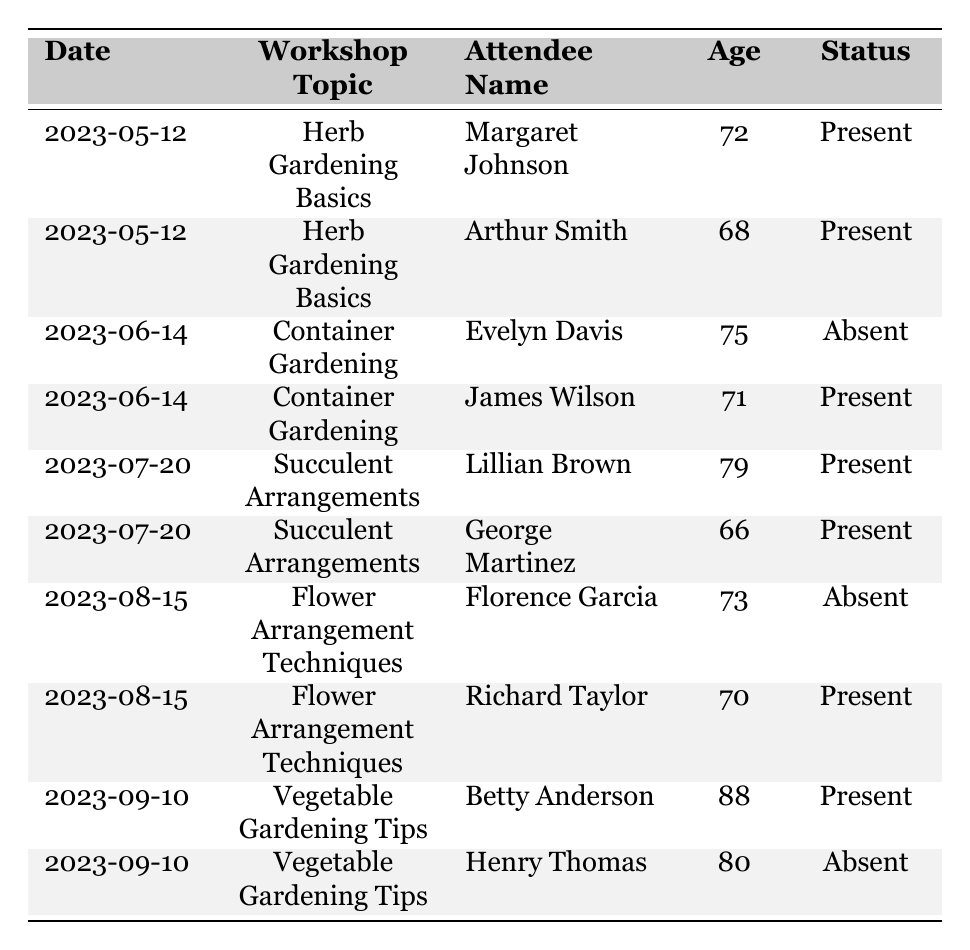What is the attendance status of Margaret Johnson? According to the table, Margaret Johnson attended the workshop on Herb Gardening Basics on 2023-05-12 and her status is listed as "Present."
Answer: Present How many seniors attended the Container Gardening workshop? The table shows that on 2023-06-14, there were two attendees listed: Evelyn Davis (Absent) and James Wilson (Present). Therefore, the number of attendees who were present is one.
Answer: 1 Which workshop had the oldest attendee? In the table, Betty Anderson, who is 88, attended the Vegetable Gardening Tips workshop on 2023-09-10. This is the highest age recorded for any attendee.
Answer: Vegetable Gardening Tips Did Richard Taylor attend the workshop on Flower Arrangement Techniques? The table indicates that Richard Taylor was present at the Flower Arrangement Techniques workshop on 2023-08-15, so he did attend.
Answer: Yes What percentage of attendees were present for the Succulent Arrangements workshop? The table lists two attendees for the Succulent Arrangements workshop on 2023-07-20: Lillian Brown and George Martinez, both of whom were present. The calculation is (2 present / 2 total) * 100 = 100%.
Answer: 100% How many workshops had both present and absent attendees? The table contains three workshops where at least one attendee is marked as present and another as absent: Container Gardening (one present, one absent), Flower Arrangement Techniques (one present, one absent), and Vegetable Gardening Tips (one present, one absent). This totals three workshops.
Answer: 3 Is there any attendee who has attended multiple workshops? By examining the table, each attendee is listed only once for each workshop, with no repeated names across the workshops, meaning no attendee has participated in multiple workshops.
Answer: No What is the average age of attendees who were present at workshops? The attendees who were present are Margaret Johnson (72), Arthur Smith (68), James Wilson (71), Lillian Brown (79), George Martinez (66), Richard Taylor (70), and Betty Anderson (88). Summing these ages gives 72 + 68 + 71 + 79 + 66 + 70 + 88 = 504. There are 7 attendees present, so the average age is 504 / 7 = 72. This averages out to approximately 72 years.
Answer: 72 Which workshop had the least number of seniors attending? Checking the table, self-identified attendance shows that Herb Gardening Basics had two attendees (both present), and the rest had at least one present as well, making it the workshop with minimal overall attendance.
Answer: Herb Gardening Basics Was there any workshop where no seniors were marked as present? The data shows that all workshops had at least one attendee marked as present; hence, no workshop has zero attendees marked present.
Answer: No 